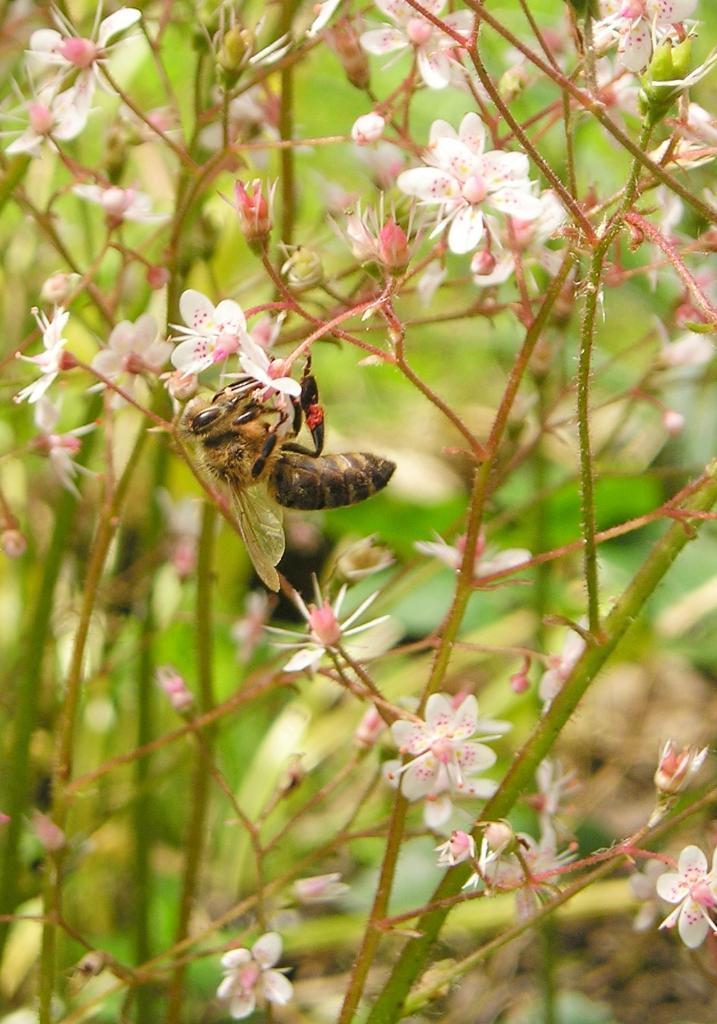In one or two sentences, can you explain what this image depicts? In the center of this picture we ca see a fly and we can see the flowers and some buds. In the background we can see some other objects. 